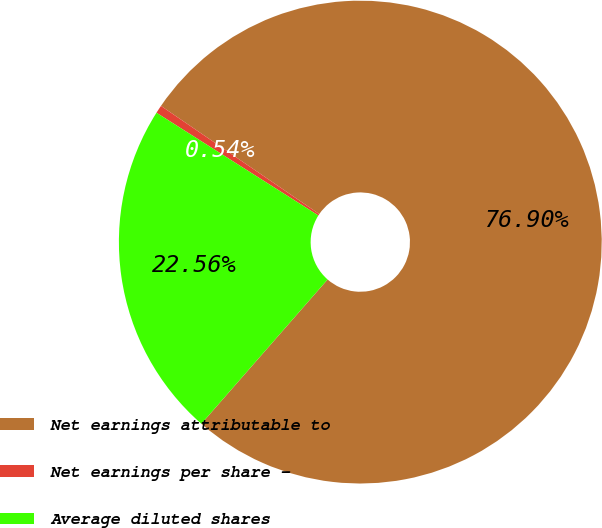Convert chart. <chart><loc_0><loc_0><loc_500><loc_500><pie_chart><fcel>Net earnings attributable to<fcel>Net earnings per share -<fcel>Average diluted shares<nl><fcel>76.9%<fcel>0.54%<fcel>22.56%<nl></chart> 